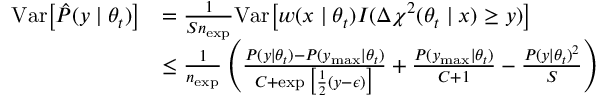Convert formula to latex. <formula><loc_0><loc_0><loc_500><loc_500>\begin{array} { r l } { V a r \left [ \hat { P } ( y | \theta _ { t } ) \right ] } & { = \frac { 1 } { S n _ { e x p } } V a r \left [ w ( x | \theta _ { t } ) I ( \Delta \chi ^ { 2 } ( \theta _ { t } | x ) \geq y ) \right ] } \\ & { \leq \frac { 1 } { n _ { e x p } } \left ( \frac { P ( y | \theta _ { t } ) - P ( y _ { \max } | \theta _ { t } ) } { C + \exp \left [ \frac { 1 } { 2 } ( y - \epsilon ) \right ] } + \frac { P ( y _ { \max } | \theta _ { t } ) } { C + 1 } - \frac { P ( y | \theta _ { t } ) ^ { 2 } } { S } \right ) } \end{array}</formula> 